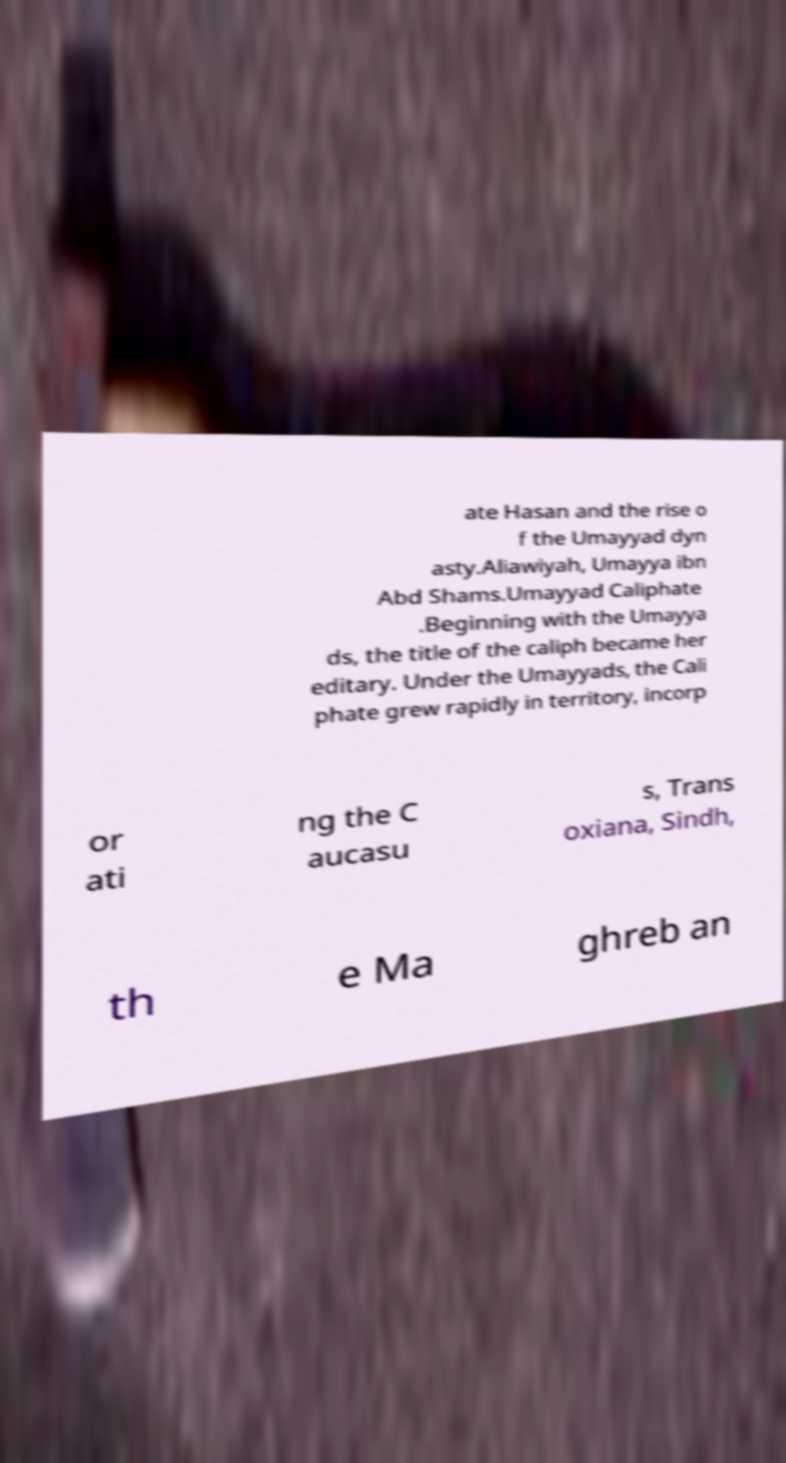Can you accurately transcribe the text from the provided image for me? ate Hasan and the rise o f the Umayyad dyn asty.Aliawiyah, Umayya ibn Abd Shams.Umayyad Caliphate .Beginning with the Umayya ds, the title of the caliph became her editary. Under the Umayyads, the Cali phate grew rapidly in territory, incorp or ati ng the C aucasu s, Trans oxiana, Sindh, th e Ma ghreb an 